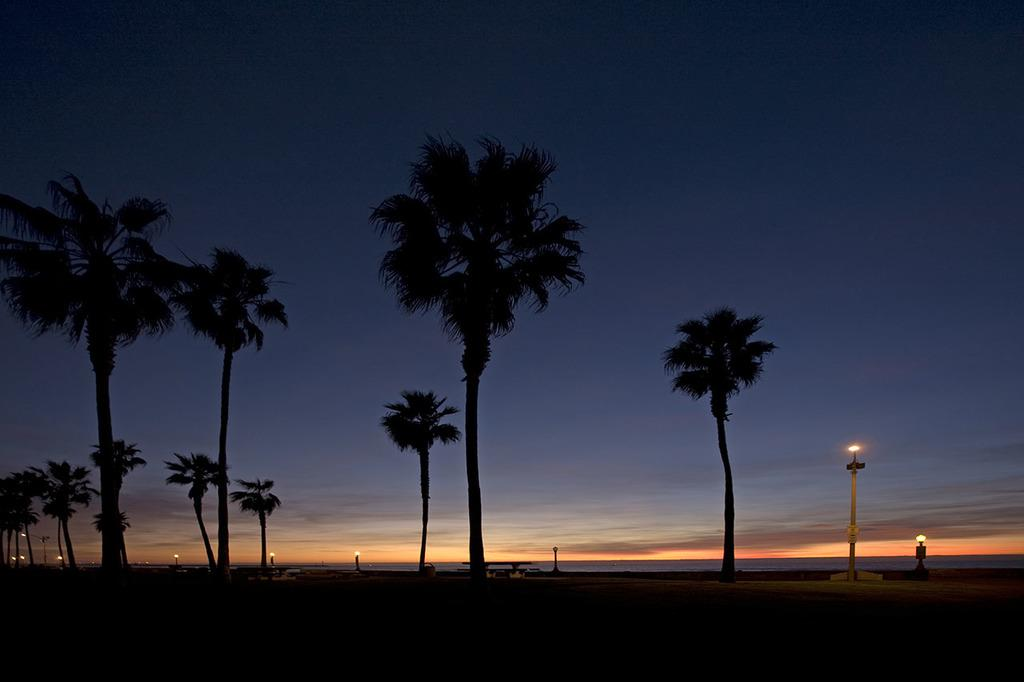What type of vegetation can be seen in the image? There are trees in the image. What objects are present that provide illumination? There are lights in the image. What structures are supporting the lights? There are poles in the image. What can be seen in the distance? The sky is visible in the background of the image. What type of game is being played in the image? There is no game present in the image. 